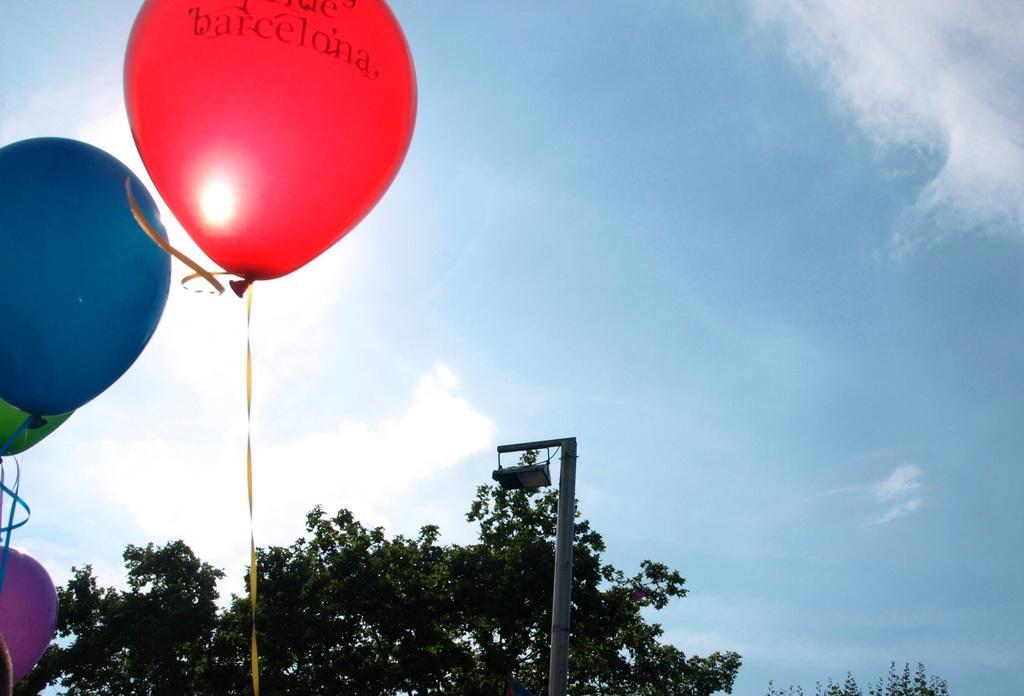Can you describe this image briefly? In this picture we can see few balloons, trees and a pole, and also we can see clouds. 